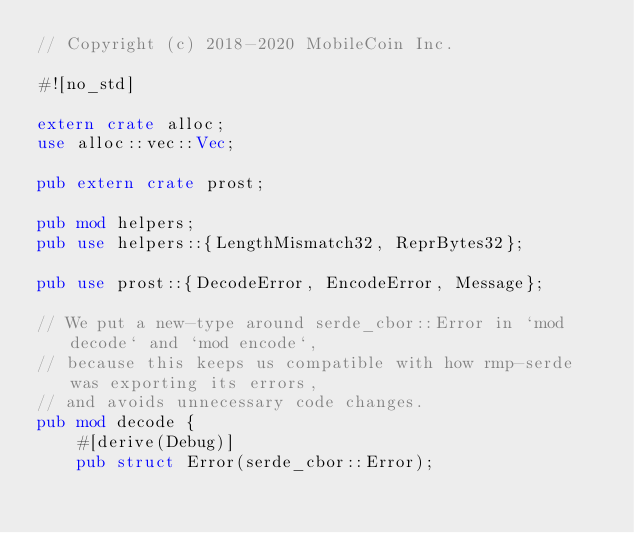<code> <loc_0><loc_0><loc_500><loc_500><_Rust_>// Copyright (c) 2018-2020 MobileCoin Inc.

#![no_std]

extern crate alloc;
use alloc::vec::Vec;

pub extern crate prost;

pub mod helpers;
pub use helpers::{LengthMismatch32, ReprBytes32};

pub use prost::{DecodeError, EncodeError, Message};

// We put a new-type around serde_cbor::Error in `mod decode` and `mod encode`,
// because this keeps us compatible with how rmp-serde was exporting its errors,
// and avoids unnecessary code changes.
pub mod decode {
    #[derive(Debug)]
    pub struct Error(serde_cbor::Error);
</code> 